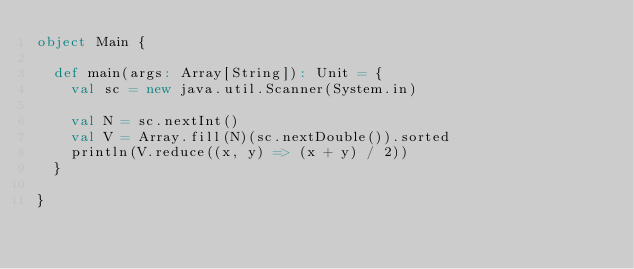<code> <loc_0><loc_0><loc_500><loc_500><_Scala_>object Main {

  def main(args: Array[String]): Unit = {
    val sc = new java.util.Scanner(System.in)

    val N = sc.nextInt()
    val V = Array.fill(N)(sc.nextDouble()).sorted
    println(V.reduce((x, y) => (x + y) / 2))
  }

}</code> 